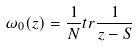<formula> <loc_0><loc_0><loc_500><loc_500>\omega _ { 0 } ( z ) = { \frac { 1 } { N } } t r { \frac { 1 } { z - S } }</formula> 